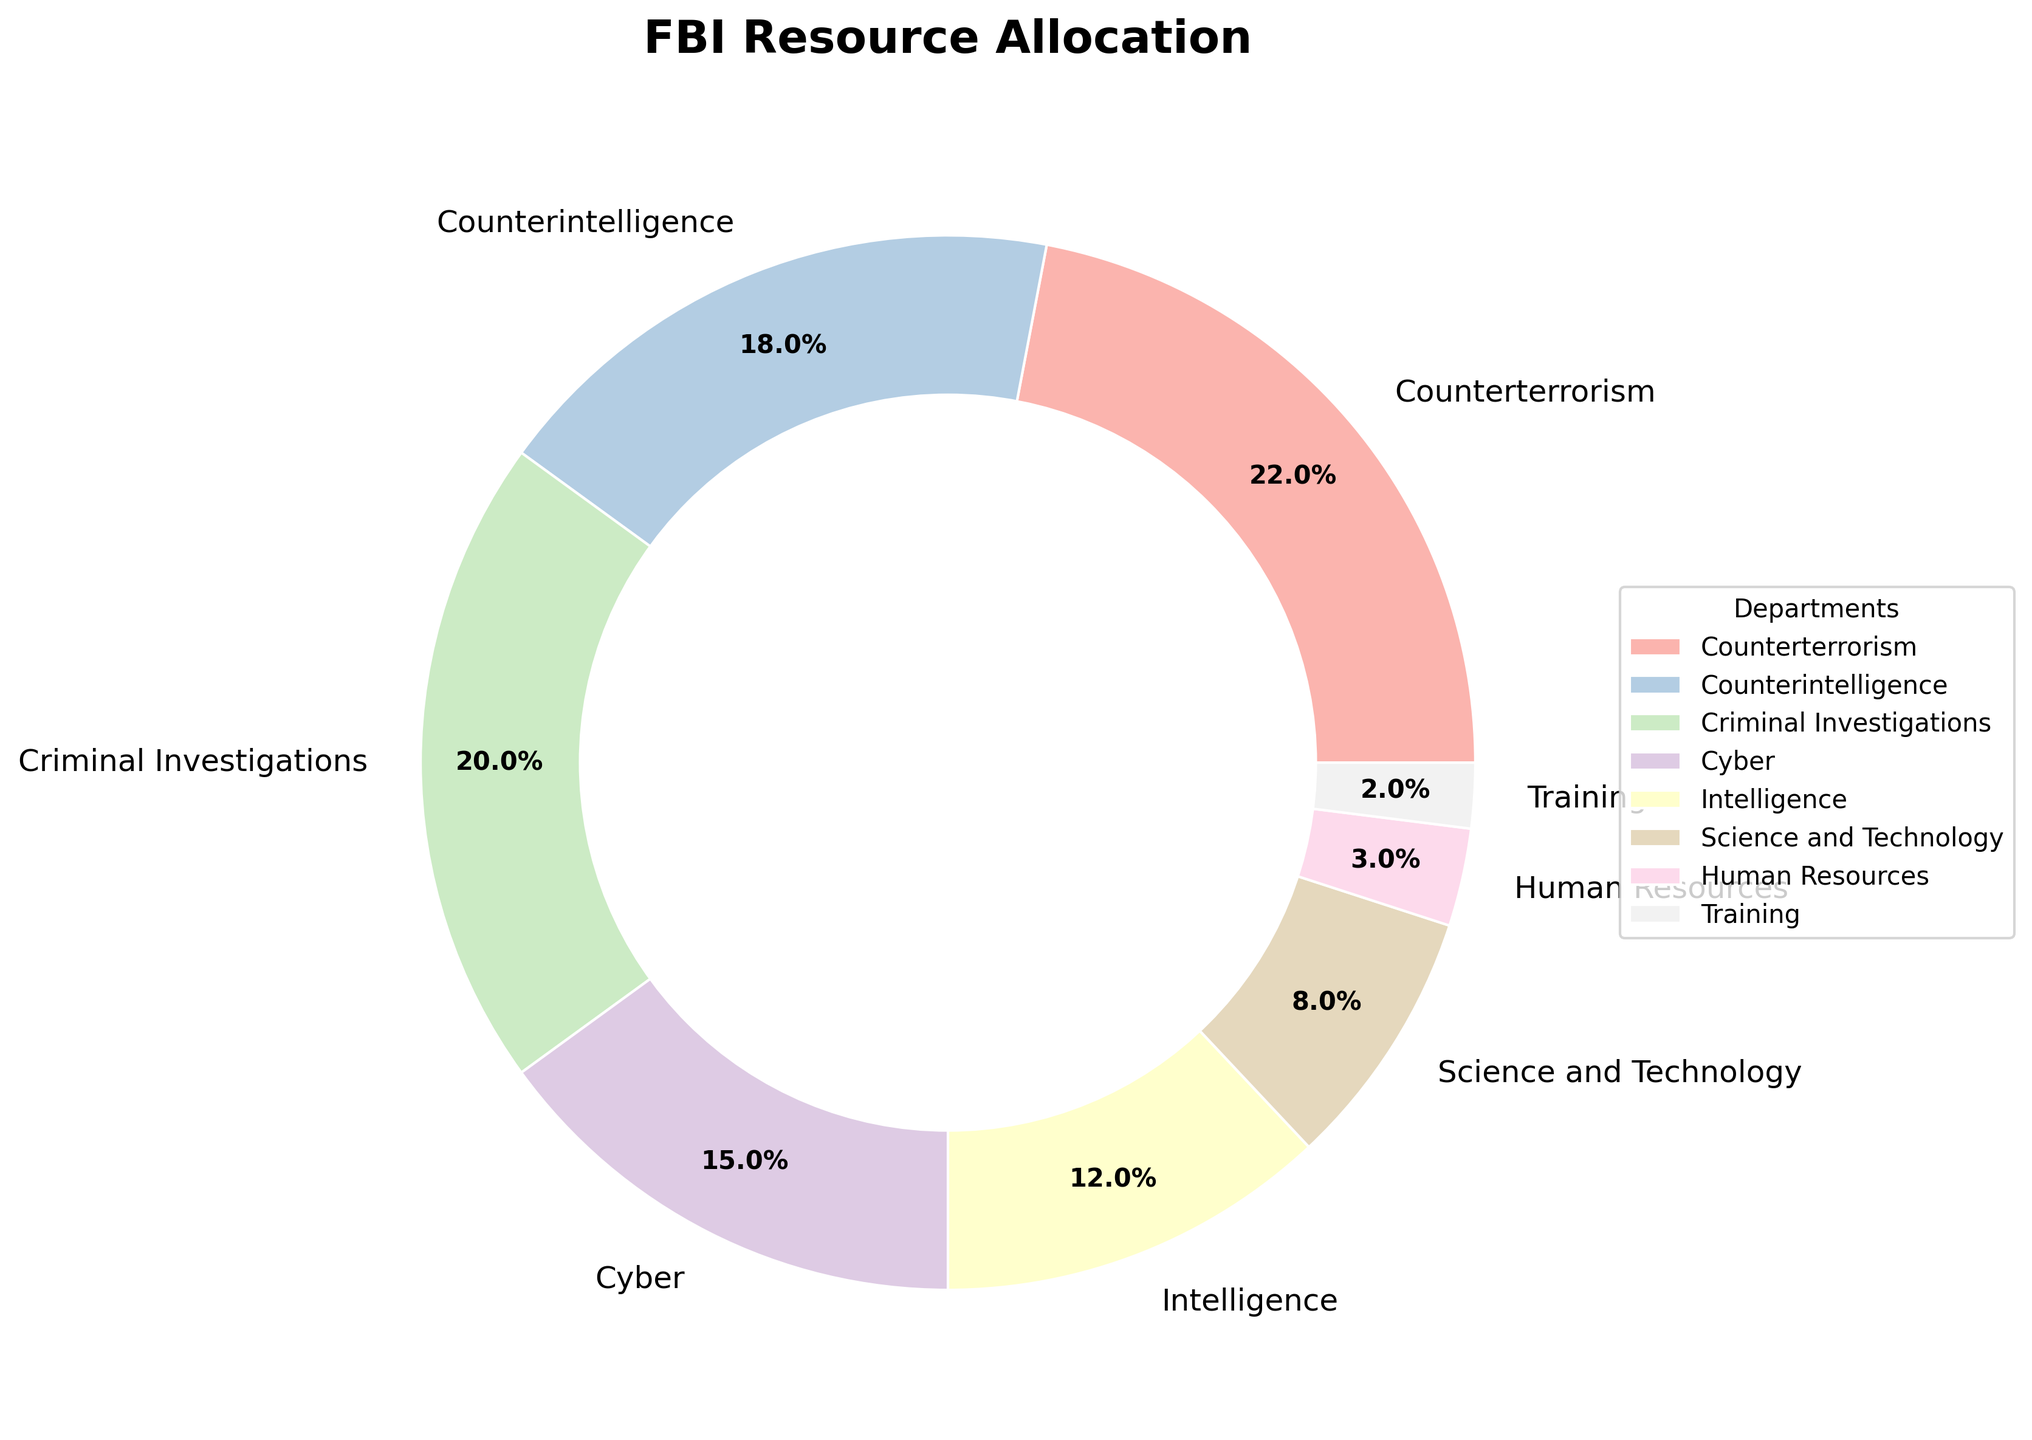Which department receives the largest budget allocation? The department with the largest budget allocation can be identified as the largest wedge in the pie chart. By visually examining the wedges, we see that the Counterterrorism department has the largest wedge, indicating the highest percentage.
Answer: Counterterrorism Which department receives the least budget allocation? The department with the smallest budget allocation can be identified as the smallest wedge in the pie chart. By examining the wedges, we see that the Training department has the smallest wedge, indicating the lowest percentage.
Answer: Training Combined, how much of the budget is allocated to Counterterrorism and Counterintelligence? To find the combined allocation, sum the percentages of the Counterterrorism and Counterintelligence departments. Counterterrorism has 22%, and Counterintelligence has 18%. Combining them, we get 22% + 18% = 40%.
Answer: 40% Is the budget allocation for Criminal Investigations greater than that for Intelligence? To determine this, compare the percentages for the Criminal Investigations and Intelligence departments from the pie chart. Criminal Investigations is 20%, and Intelligence is 12%. Since 20% is greater than 12%, the answer is yes.
Answer: Yes What is the total budget allocation for the departments related to technology (Cyber and Science and Technology)? To find this, sum the percentages for the Cyber and Science and Technology departments. Cyber has 15%, and Science and Technology has 8%. The combined allocation is 15% + 8% = 23%.
Answer: 23% Is the proportion of the budget allocated to Human Resources twice as much as the budget allocated to Training? Compare the percentage for Human Resources to twice the percentage for Training. Human Resources has 3%, and Training has 2%. Twice the Training budget is 2% * 2 = 4%. Since 3% is not equal to 4%, the answer is no.
Answer: No Which departments have a budget allocation percentage greater than 15%? Identify the departments whose wedges in the pie chart represent more than 15%. The percentages greater than 15% are for Counterterrorism (22%), Counterintelligence (18%), and Criminal Investigations (20%).
Answer: Counterterrorism, Counterintelligence, Criminal Investigations If the budget allocation for Intelligence were doubled, would it surpass the allocation for Criminal Investigations? Calculate double the Intelligence budget and compare it to the Criminal Investigations budget. Double the Intelligence budget is 12% * 2 = 24%. The Criminal Investigations budget is 20%. Since 24% is greater than 20%, the answer is yes.
Answer: Yes How much more budget allocation does Counterterrorism receive compared to Cyber? Subtract the percentage of Cyber from Counterterrorism's percentage. Counterterrorism is 22%, and Cyber is 15%. The difference is 22% - 15% = 7%.
Answer: 7% What is the average budget allocation for Science and Technology, Human Resources, and Training? To find the average, sum the percentages for these departments and then divide by 3. Science and Technology is 8%, Human Resources is 3%, and Training is 2%. Sum: 8% + 3% + 2% = 13%. Average: 13% / 3 ≈ 4.33%.
Answer: 4.33% 